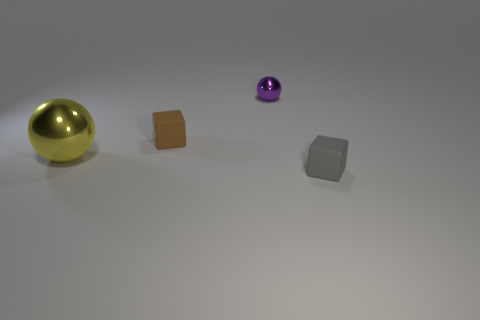Subtract all brown cubes. How many cubes are left? 1 Subtract 0 brown cylinders. How many objects are left? 4 Subtract 2 spheres. How many spheres are left? 0 Subtract all gray spheres. Subtract all yellow cylinders. How many spheres are left? 2 Subtract all red cylinders. How many brown blocks are left? 1 Subtract all small brown objects. Subtract all big blue cylinders. How many objects are left? 3 Add 4 large yellow metal balls. How many large yellow metal balls are left? 5 Add 1 big spheres. How many big spheres exist? 2 Add 1 large green blocks. How many objects exist? 5 